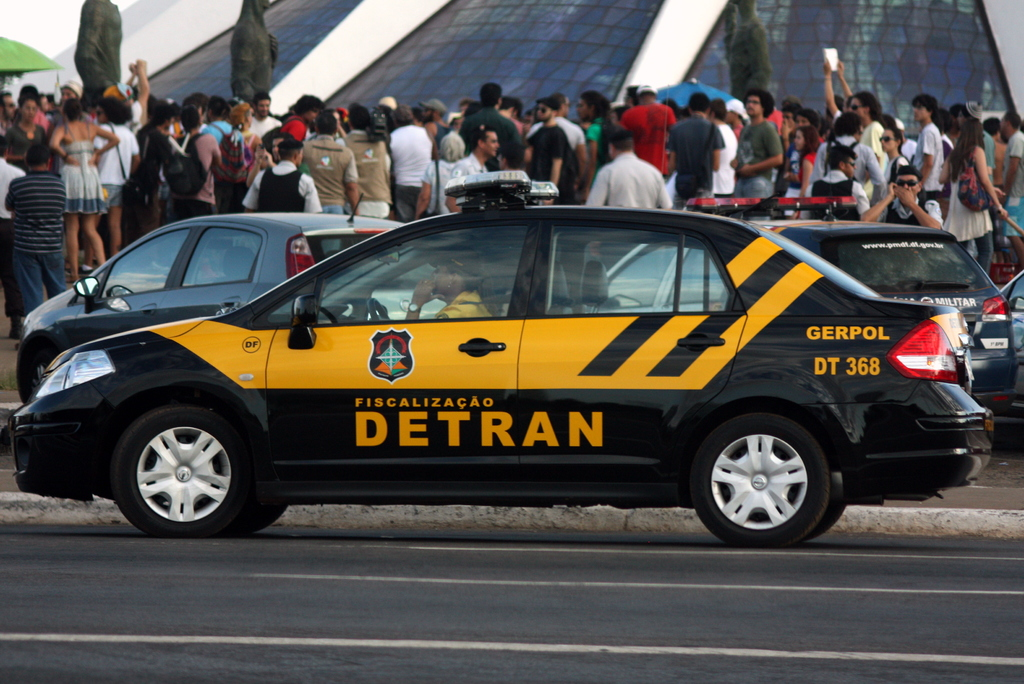Is DETRAN responsible for any specific types of vehicles or traffic regulations? DETRAN is typically responsible for traffic regulation, vehicle registration, and driver licensing in Brazil. They may also enforce laws relating to road safety and vehicle roadworthiness. How does their presence influence public perception during such events? The presence of DETRAN at public events likely reassures the public about safety and regulatory observance, helping maintain order and prevent incidents related to traffic and crowds. 